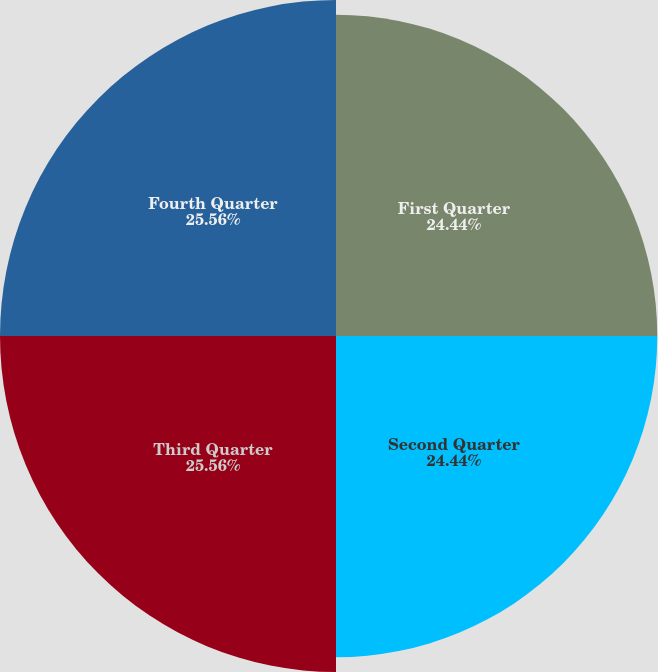Convert chart to OTSL. <chart><loc_0><loc_0><loc_500><loc_500><pie_chart><fcel>First Quarter<fcel>Second Quarter<fcel>Third Quarter<fcel>Fourth Quarter<nl><fcel>24.44%<fcel>24.44%<fcel>25.56%<fcel>25.56%<nl></chart> 